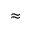<formula> <loc_0><loc_0><loc_500><loc_500>\approx</formula> 